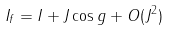Convert formula to latex. <formula><loc_0><loc_0><loc_500><loc_500>I _ { f } = I + J \cos g + O ( J ^ { 2 } )</formula> 